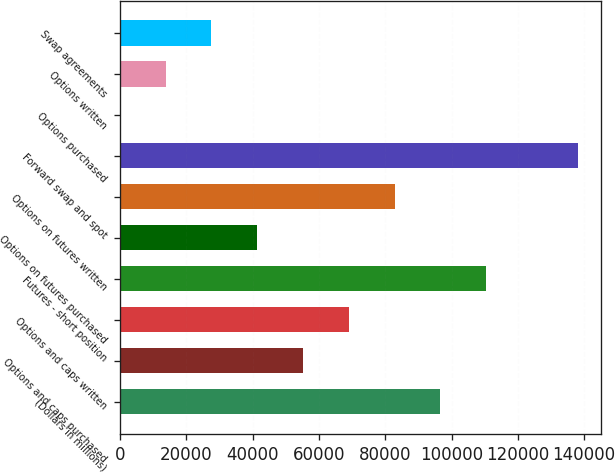Convert chart to OTSL. <chart><loc_0><loc_0><loc_500><loc_500><bar_chart><fcel>(Dollars in millions)<fcel>Options and caps purchased<fcel>Options and caps written<fcel>Futures - short position<fcel>Options on futures purchased<fcel>Options on futures written<fcel>Forward swap and spot<fcel>Options purchased<fcel>Options written<fcel>Swap agreements<nl><fcel>96640.5<fcel>55224<fcel>69029.5<fcel>110446<fcel>41418.5<fcel>82835<fcel>138057<fcel>2<fcel>13807.5<fcel>27613<nl></chart> 